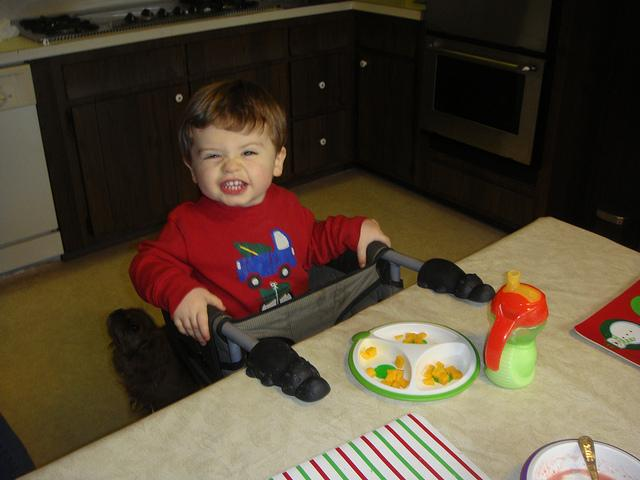What kind of plate is the boy using?

Choices:
A) muppet
B) soup
C) divider
D) bread divider 